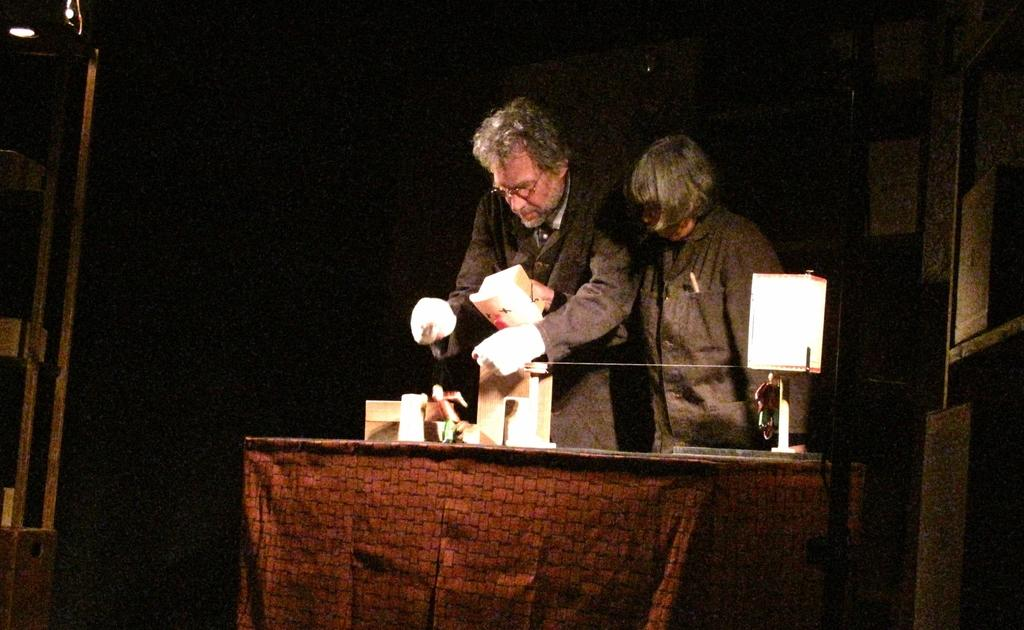How many people are in the image? There are two persons in the image. What are the persons wearing? The persons are wearing black dress. Where are the persons standing in relation to the table? The persons are standing in front of a table. What is on the table? There is a lamp and other objects on the table. What is the lighting condition in the image? The background of the image is dark. What type of cable can be seen in the image? There is no cable present in the image. 